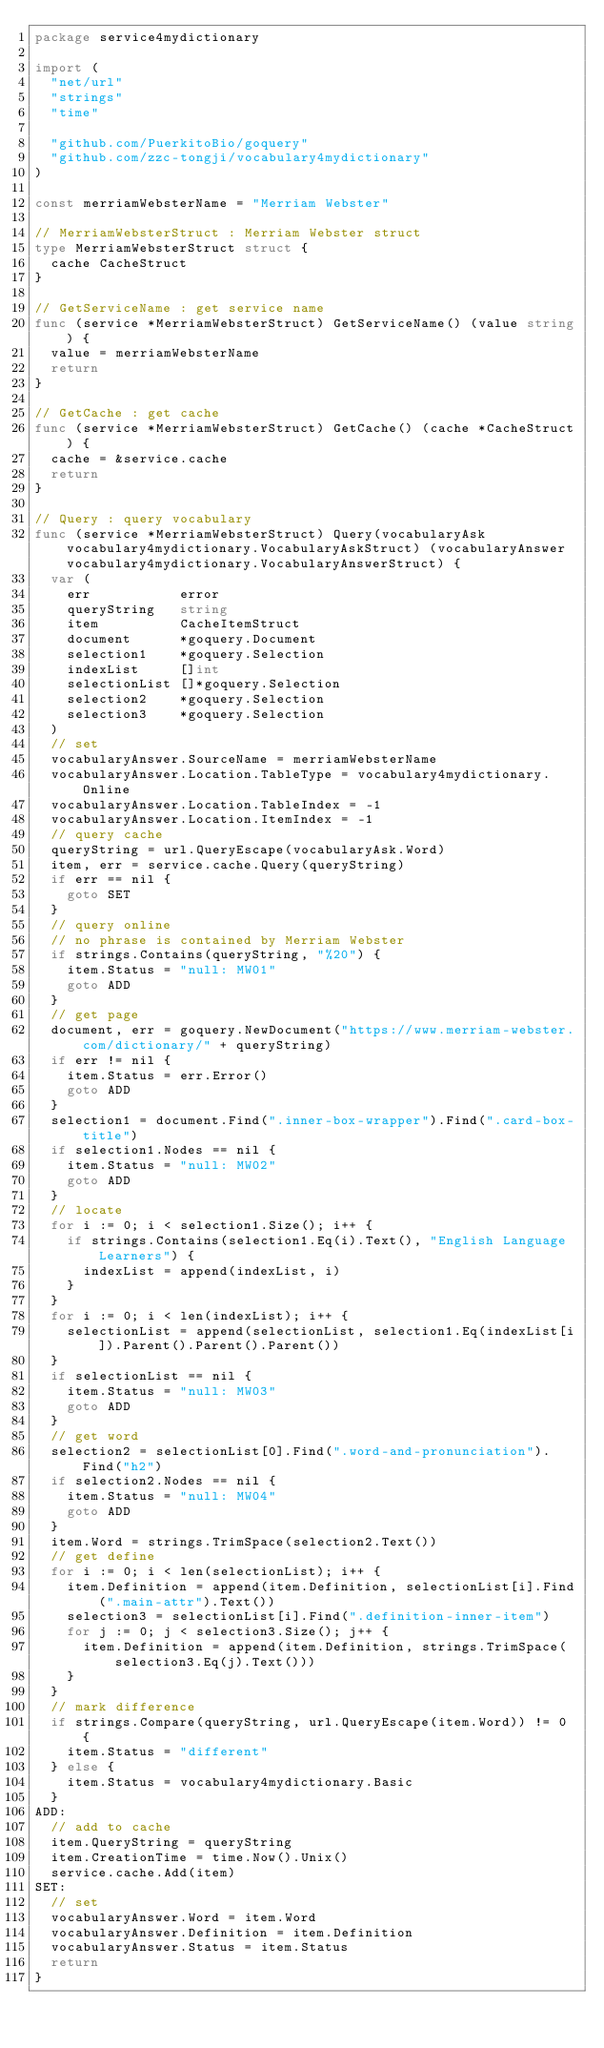<code> <loc_0><loc_0><loc_500><loc_500><_Go_>package service4mydictionary

import (
	"net/url"
	"strings"
	"time"

	"github.com/PuerkitoBio/goquery"
	"github.com/zzc-tongji/vocabulary4mydictionary"
)

const merriamWebsterName = "Merriam Webster"

// MerriamWebsterStruct : Merriam Webster struct
type MerriamWebsterStruct struct {
	cache CacheStruct
}

// GetServiceName : get service name
func (service *MerriamWebsterStruct) GetServiceName() (value string) {
	value = merriamWebsterName
	return
}

// GetCache : get cache
func (service *MerriamWebsterStruct) GetCache() (cache *CacheStruct) {
	cache = &service.cache
	return
}

// Query : query vocabulary
func (service *MerriamWebsterStruct) Query(vocabularyAsk vocabulary4mydictionary.VocabularyAskStruct) (vocabularyAnswer vocabulary4mydictionary.VocabularyAnswerStruct) {
	var (
		err           error
		queryString   string
		item          CacheItemStruct
		document      *goquery.Document
		selection1    *goquery.Selection
		indexList     []int
		selectionList []*goquery.Selection
		selection2    *goquery.Selection
		selection3    *goquery.Selection
	)
	// set
	vocabularyAnswer.SourceName = merriamWebsterName
	vocabularyAnswer.Location.TableType = vocabulary4mydictionary.Online
	vocabularyAnswer.Location.TableIndex = -1
	vocabularyAnswer.Location.ItemIndex = -1
	// query cache
	queryString = url.QueryEscape(vocabularyAsk.Word)
	item, err = service.cache.Query(queryString)
	if err == nil {
		goto SET
	}
	// query online
	// no phrase is contained by Merriam Webster
	if strings.Contains(queryString, "%20") {
		item.Status = "null: MW01"
		goto ADD
	}
	// get page
	document, err = goquery.NewDocument("https://www.merriam-webster.com/dictionary/" + queryString)
	if err != nil {
		item.Status = err.Error()
		goto ADD
	}
	selection1 = document.Find(".inner-box-wrapper").Find(".card-box-title")
	if selection1.Nodes == nil {
		item.Status = "null: MW02"
		goto ADD
	}
	// locate
	for i := 0; i < selection1.Size(); i++ {
		if strings.Contains(selection1.Eq(i).Text(), "English Language Learners") {
			indexList = append(indexList, i)
		}
	}
	for i := 0; i < len(indexList); i++ {
		selectionList = append(selectionList, selection1.Eq(indexList[i]).Parent().Parent().Parent())
	}
	if selectionList == nil {
		item.Status = "null: MW03"
		goto ADD
	}
	// get word
	selection2 = selectionList[0].Find(".word-and-pronunciation").Find("h2")
	if selection2.Nodes == nil {
		item.Status = "null: MW04"
		goto ADD
	}
	item.Word = strings.TrimSpace(selection2.Text())
	// get define
	for i := 0; i < len(selectionList); i++ {
		item.Definition = append(item.Definition, selectionList[i].Find(".main-attr").Text())
		selection3 = selectionList[i].Find(".definition-inner-item")
		for j := 0; j < selection3.Size(); j++ {
			item.Definition = append(item.Definition, strings.TrimSpace(selection3.Eq(j).Text()))
		}
	}
	// mark difference
	if strings.Compare(queryString, url.QueryEscape(item.Word)) != 0 {
		item.Status = "different"
	} else {
		item.Status = vocabulary4mydictionary.Basic
	}
ADD:
	// add to cache
	item.QueryString = queryString
	item.CreationTime = time.Now().Unix()
	service.cache.Add(item)
SET:
	// set
	vocabularyAnswer.Word = item.Word
	vocabularyAnswer.Definition = item.Definition
	vocabularyAnswer.Status = item.Status
	return
}
</code> 